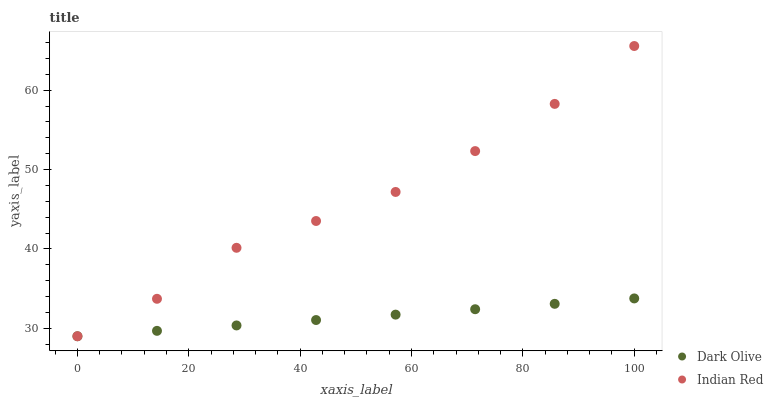Does Dark Olive have the minimum area under the curve?
Answer yes or no. Yes. Does Indian Red have the maximum area under the curve?
Answer yes or no. Yes. Does Indian Red have the minimum area under the curve?
Answer yes or no. No. Is Dark Olive the smoothest?
Answer yes or no. Yes. Is Indian Red the roughest?
Answer yes or no. Yes. Is Indian Red the smoothest?
Answer yes or no. No. Does Dark Olive have the lowest value?
Answer yes or no. Yes. Does Indian Red have the highest value?
Answer yes or no. Yes. Does Dark Olive intersect Indian Red?
Answer yes or no. Yes. Is Dark Olive less than Indian Red?
Answer yes or no. No. Is Dark Olive greater than Indian Red?
Answer yes or no. No. 